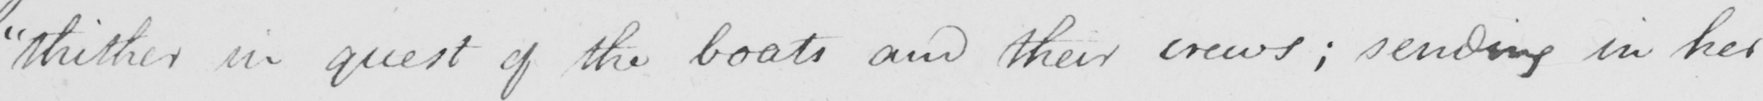Transcribe the text shown in this historical manuscript line. " thither , in quest of the boats and their crews ; sending in her 